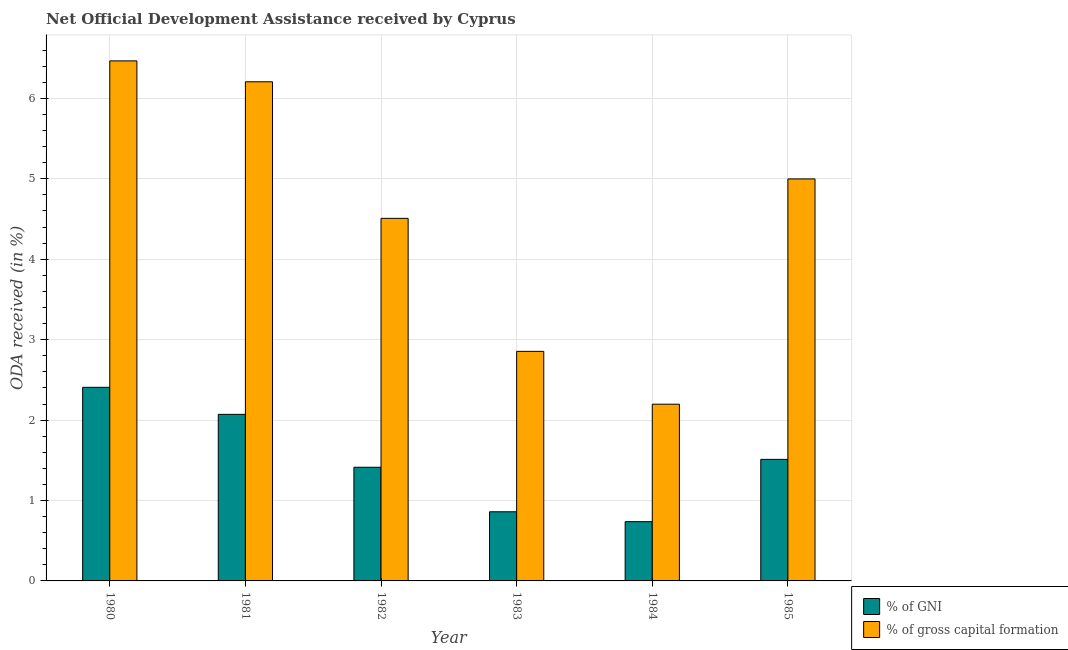Are the number of bars per tick equal to the number of legend labels?
Give a very brief answer. Yes. In how many cases, is the number of bars for a given year not equal to the number of legend labels?
Make the answer very short. 0. What is the oda received as percentage of gross capital formation in 1984?
Give a very brief answer. 2.2. Across all years, what is the maximum oda received as percentage of gross capital formation?
Give a very brief answer. 6.47. Across all years, what is the minimum oda received as percentage of gross capital formation?
Ensure brevity in your answer.  2.2. In which year was the oda received as percentage of gni maximum?
Your answer should be very brief. 1980. What is the total oda received as percentage of gross capital formation in the graph?
Make the answer very short. 27.23. What is the difference between the oda received as percentage of gni in 1983 and that in 1984?
Provide a short and direct response. 0.12. What is the difference between the oda received as percentage of gni in 1984 and the oda received as percentage of gross capital formation in 1982?
Give a very brief answer. -0.68. What is the average oda received as percentage of gross capital formation per year?
Ensure brevity in your answer.  4.54. In how many years, is the oda received as percentage of gross capital formation greater than 5.2 %?
Your answer should be compact. 2. What is the ratio of the oda received as percentage of gross capital formation in 1980 to that in 1981?
Offer a very short reply. 1.04. Is the oda received as percentage of gni in 1980 less than that in 1985?
Provide a short and direct response. No. What is the difference between the highest and the second highest oda received as percentage of gross capital formation?
Your answer should be compact. 0.26. What is the difference between the highest and the lowest oda received as percentage of gni?
Keep it short and to the point. 1.67. In how many years, is the oda received as percentage of gross capital formation greater than the average oda received as percentage of gross capital formation taken over all years?
Your answer should be compact. 3. What does the 1st bar from the left in 1980 represents?
Give a very brief answer. % of GNI. What does the 1st bar from the right in 1982 represents?
Keep it short and to the point. % of gross capital formation. What is the difference between two consecutive major ticks on the Y-axis?
Provide a short and direct response. 1. Are the values on the major ticks of Y-axis written in scientific E-notation?
Ensure brevity in your answer.  No. Does the graph contain grids?
Provide a succinct answer. Yes. What is the title of the graph?
Your answer should be compact. Net Official Development Assistance received by Cyprus. Does "Investment in Transport" appear as one of the legend labels in the graph?
Your answer should be compact. No. What is the label or title of the Y-axis?
Give a very brief answer. ODA received (in %). What is the ODA received (in %) in % of GNI in 1980?
Give a very brief answer. 2.41. What is the ODA received (in %) of % of gross capital formation in 1980?
Offer a very short reply. 6.47. What is the ODA received (in %) of % of GNI in 1981?
Provide a short and direct response. 2.07. What is the ODA received (in %) of % of gross capital formation in 1981?
Your answer should be compact. 6.21. What is the ODA received (in %) of % of GNI in 1982?
Your response must be concise. 1.41. What is the ODA received (in %) in % of gross capital formation in 1982?
Offer a terse response. 4.51. What is the ODA received (in %) of % of GNI in 1983?
Your response must be concise. 0.86. What is the ODA received (in %) of % of gross capital formation in 1983?
Offer a terse response. 2.85. What is the ODA received (in %) in % of GNI in 1984?
Your answer should be compact. 0.74. What is the ODA received (in %) in % of gross capital formation in 1984?
Ensure brevity in your answer.  2.2. What is the ODA received (in %) in % of GNI in 1985?
Your answer should be very brief. 1.51. What is the ODA received (in %) in % of gross capital formation in 1985?
Ensure brevity in your answer.  5. Across all years, what is the maximum ODA received (in %) in % of GNI?
Offer a very short reply. 2.41. Across all years, what is the maximum ODA received (in %) of % of gross capital formation?
Provide a short and direct response. 6.47. Across all years, what is the minimum ODA received (in %) of % of GNI?
Make the answer very short. 0.74. Across all years, what is the minimum ODA received (in %) in % of gross capital formation?
Provide a succinct answer. 2.2. What is the total ODA received (in %) of % of GNI in the graph?
Give a very brief answer. 9. What is the total ODA received (in %) in % of gross capital formation in the graph?
Make the answer very short. 27.23. What is the difference between the ODA received (in %) in % of GNI in 1980 and that in 1981?
Ensure brevity in your answer.  0.34. What is the difference between the ODA received (in %) in % of gross capital formation in 1980 and that in 1981?
Keep it short and to the point. 0.26. What is the difference between the ODA received (in %) of % of GNI in 1980 and that in 1982?
Ensure brevity in your answer.  0.99. What is the difference between the ODA received (in %) of % of gross capital formation in 1980 and that in 1982?
Provide a short and direct response. 1.96. What is the difference between the ODA received (in %) in % of GNI in 1980 and that in 1983?
Your answer should be compact. 1.55. What is the difference between the ODA received (in %) in % of gross capital formation in 1980 and that in 1983?
Keep it short and to the point. 3.61. What is the difference between the ODA received (in %) of % of GNI in 1980 and that in 1984?
Provide a succinct answer. 1.67. What is the difference between the ODA received (in %) in % of gross capital formation in 1980 and that in 1984?
Make the answer very short. 4.27. What is the difference between the ODA received (in %) in % of GNI in 1980 and that in 1985?
Provide a succinct answer. 0.9. What is the difference between the ODA received (in %) in % of gross capital formation in 1980 and that in 1985?
Make the answer very short. 1.47. What is the difference between the ODA received (in %) of % of GNI in 1981 and that in 1982?
Provide a short and direct response. 0.66. What is the difference between the ODA received (in %) of % of gross capital formation in 1981 and that in 1982?
Provide a short and direct response. 1.7. What is the difference between the ODA received (in %) in % of GNI in 1981 and that in 1983?
Offer a terse response. 1.21. What is the difference between the ODA received (in %) in % of gross capital formation in 1981 and that in 1983?
Offer a very short reply. 3.35. What is the difference between the ODA received (in %) in % of GNI in 1981 and that in 1984?
Give a very brief answer. 1.33. What is the difference between the ODA received (in %) in % of gross capital formation in 1981 and that in 1984?
Give a very brief answer. 4.01. What is the difference between the ODA received (in %) in % of GNI in 1981 and that in 1985?
Keep it short and to the point. 0.56. What is the difference between the ODA received (in %) in % of gross capital formation in 1981 and that in 1985?
Your answer should be compact. 1.21. What is the difference between the ODA received (in %) of % of GNI in 1982 and that in 1983?
Offer a very short reply. 0.55. What is the difference between the ODA received (in %) of % of gross capital formation in 1982 and that in 1983?
Ensure brevity in your answer.  1.65. What is the difference between the ODA received (in %) in % of GNI in 1982 and that in 1984?
Your answer should be compact. 0.68. What is the difference between the ODA received (in %) of % of gross capital formation in 1982 and that in 1984?
Offer a very short reply. 2.31. What is the difference between the ODA received (in %) of % of GNI in 1982 and that in 1985?
Keep it short and to the point. -0.1. What is the difference between the ODA received (in %) in % of gross capital formation in 1982 and that in 1985?
Ensure brevity in your answer.  -0.49. What is the difference between the ODA received (in %) of % of GNI in 1983 and that in 1984?
Your answer should be very brief. 0.12. What is the difference between the ODA received (in %) in % of gross capital formation in 1983 and that in 1984?
Your answer should be very brief. 0.66. What is the difference between the ODA received (in %) of % of GNI in 1983 and that in 1985?
Ensure brevity in your answer.  -0.65. What is the difference between the ODA received (in %) in % of gross capital formation in 1983 and that in 1985?
Provide a short and direct response. -2.14. What is the difference between the ODA received (in %) of % of GNI in 1984 and that in 1985?
Ensure brevity in your answer.  -0.77. What is the difference between the ODA received (in %) of % of gross capital formation in 1984 and that in 1985?
Offer a terse response. -2.8. What is the difference between the ODA received (in %) of % of GNI in 1980 and the ODA received (in %) of % of gross capital formation in 1981?
Give a very brief answer. -3.8. What is the difference between the ODA received (in %) in % of GNI in 1980 and the ODA received (in %) in % of gross capital formation in 1982?
Your response must be concise. -2.1. What is the difference between the ODA received (in %) in % of GNI in 1980 and the ODA received (in %) in % of gross capital formation in 1983?
Make the answer very short. -0.45. What is the difference between the ODA received (in %) of % of GNI in 1980 and the ODA received (in %) of % of gross capital formation in 1984?
Your answer should be compact. 0.21. What is the difference between the ODA received (in %) of % of GNI in 1980 and the ODA received (in %) of % of gross capital formation in 1985?
Provide a succinct answer. -2.59. What is the difference between the ODA received (in %) of % of GNI in 1981 and the ODA received (in %) of % of gross capital formation in 1982?
Provide a short and direct response. -2.44. What is the difference between the ODA received (in %) of % of GNI in 1981 and the ODA received (in %) of % of gross capital formation in 1983?
Ensure brevity in your answer.  -0.78. What is the difference between the ODA received (in %) of % of GNI in 1981 and the ODA received (in %) of % of gross capital formation in 1984?
Your answer should be compact. -0.13. What is the difference between the ODA received (in %) in % of GNI in 1981 and the ODA received (in %) in % of gross capital formation in 1985?
Provide a succinct answer. -2.93. What is the difference between the ODA received (in %) in % of GNI in 1982 and the ODA received (in %) in % of gross capital formation in 1983?
Offer a terse response. -1.44. What is the difference between the ODA received (in %) in % of GNI in 1982 and the ODA received (in %) in % of gross capital formation in 1984?
Your answer should be compact. -0.78. What is the difference between the ODA received (in %) of % of GNI in 1982 and the ODA received (in %) of % of gross capital formation in 1985?
Give a very brief answer. -3.59. What is the difference between the ODA received (in %) of % of GNI in 1983 and the ODA received (in %) of % of gross capital formation in 1984?
Your response must be concise. -1.34. What is the difference between the ODA received (in %) of % of GNI in 1983 and the ODA received (in %) of % of gross capital formation in 1985?
Your response must be concise. -4.14. What is the difference between the ODA received (in %) in % of GNI in 1984 and the ODA received (in %) in % of gross capital formation in 1985?
Keep it short and to the point. -4.26. What is the average ODA received (in %) in % of gross capital formation per year?
Your answer should be compact. 4.54. In the year 1980, what is the difference between the ODA received (in %) of % of GNI and ODA received (in %) of % of gross capital formation?
Your response must be concise. -4.06. In the year 1981, what is the difference between the ODA received (in %) of % of GNI and ODA received (in %) of % of gross capital formation?
Provide a succinct answer. -4.14. In the year 1982, what is the difference between the ODA received (in %) in % of GNI and ODA received (in %) in % of gross capital formation?
Your response must be concise. -3.1. In the year 1983, what is the difference between the ODA received (in %) of % of GNI and ODA received (in %) of % of gross capital formation?
Make the answer very short. -1.99. In the year 1984, what is the difference between the ODA received (in %) in % of GNI and ODA received (in %) in % of gross capital formation?
Offer a terse response. -1.46. In the year 1985, what is the difference between the ODA received (in %) in % of GNI and ODA received (in %) in % of gross capital formation?
Keep it short and to the point. -3.49. What is the ratio of the ODA received (in %) in % of GNI in 1980 to that in 1981?
Make the answer very short. 1.16. What is the ratio of the ODA received (in %) in % of gross capital formation in 1980 to that in 1981?
Ensure brevity in your answer.  1.04. What is the ratio of the ODA received (in %) of % of GNI in 1980 to that in 1982?
Offer a terse response. 1.7. What is the ratio of the ODA received (in %) in % of gross capital formation in 1980 to that in 1982?
Keep it short and to the point. 1.43. What is the ratio of the ODA received (in %) of % of GNI in 1980 to that in 1983?
Ensure brevity in your answer.  2.8. What is the ratio of the ODA received (in %) of % of gross capital formation in 1980 to that in 1983?
Your response must be concise. 2.27. What is the ratio of the ODA received (in %) in % of GNI in 1980 to that in 1984?
Make the answer very short. 3.27. What is the ratio of the ODA received (in %) of % of gross capital formation in 1980 to that in 1984?
Ensure brevity in your answer.  2.94. What is the ratio of the ODA received (in %) of % of GNI in 1980 to that in 1985?
Give a very brief answer. 1.59. What is the ratio of the ODA received (in %) in % of gross capital formation in 1980 to that in 1985?
Make the answer very short. 1.29. What is the ratio of the ODA received (in %) in % of GNI in 1981 to that in 1982?
Keep it short and to the point. 1.47. What is the ratio of the ODA received (in %) in % of gross capital formation in 1981 to that in 1982?
Your response must be concise. 1.38. What is the ratio of the ODA received (in %) in % of GNI in 1981 to that in 1983?
Your answer should be very brief. 2.41. What is the ratio of the ODA received (in %) of % of gross capital formation in 1981 to that in 1983?
Offer a very short reply. 2.17. What is the ratio of the ODA received (in %) of % of GNI in 1981 to that in 1984?
Give a very brief answer. 2.81. What is the ratio of the ODA received (in %) in % of gross capital formation in 1981 to that in 1984?
Offer a very short reply. 2.82. What is the ratio of the ODA received (in %) in % of GNI in 1981 to that in 1985?
Ensure brevity in your answer.  1.37. What is the ratio of the ODA received (in %) of % of gross capital formation in 1981 to that in 1985?
Offer a very short reply. 1.24. What is the ratio of the ODA received (in %) of % of GNI in 1982 to that in 1983?
Provide a succinct answer. 1.64. What is the ratio of the ODA received (in %) in % of gross capital formation in 1982 to that in 1983?
Ensure brevity in your answer.  1.58. What is the ratio of the ODA received (in %) in % of GNI in 1982 to that in 1984?
Provide a short and direct response. 1.92. What is the ratio of the ODA received (in %) of % of gross capital formation in 1982 to that in 1984?
Keep it short and to the point. 2.05. What is the ratio of the ODA received (in %) in % of GNI in 1982 to that in 1985?
Your answer should be very brief. 0.94. What is the ratio of the ODA received (in %) of % of gross capital formation in 1982 to that in 1985?
Your answer should be very brief. 0.9. What is the ratio of the ODA received (in %) of % of GNI in 1983 to that in 1984?
Your answer should be very brief. 1.17. What is the ratio of the ODA received (in %) in % of gross capital formation in 1983 to that in 1984?
Give a very brief answer. 1.3. What is the ratio of the ODA received (in %) of % of GNI in 1983 to that in 1985?
Provide a short and direct response. 0.57. What is the ratio of the ODA received (in %) in % of gross capital formation in 1983 to that in 1985?
Provide a short and direct response. 0.57. What is the ratio of the ODA received (in %) of % of GNI in 1984 to that in 1985?
Provide a short and direct response. 0.49. What is the ratio of the ODA received (in %) of % of gross capital formation in 1984 to that in 1985?
Keep it short and to the point. 0.44. What is the difference between the highest and the second highest ODA received (in %) in % of GNI?
Your answer should be very brief. 0.34. What is the difference between the highest and the second highest ODA received (in %) of % of gross capital formation?
Ensure brevity in your answer.  0.26. What is the difference between the highest and the lowest ODA received (in %) of % of GNI?
Offer a terse response. 1.67. What is the difference between the highest and the lowest ODA received (in %) in % of gross capital formation?
Offer a very short reply. 4.27. 